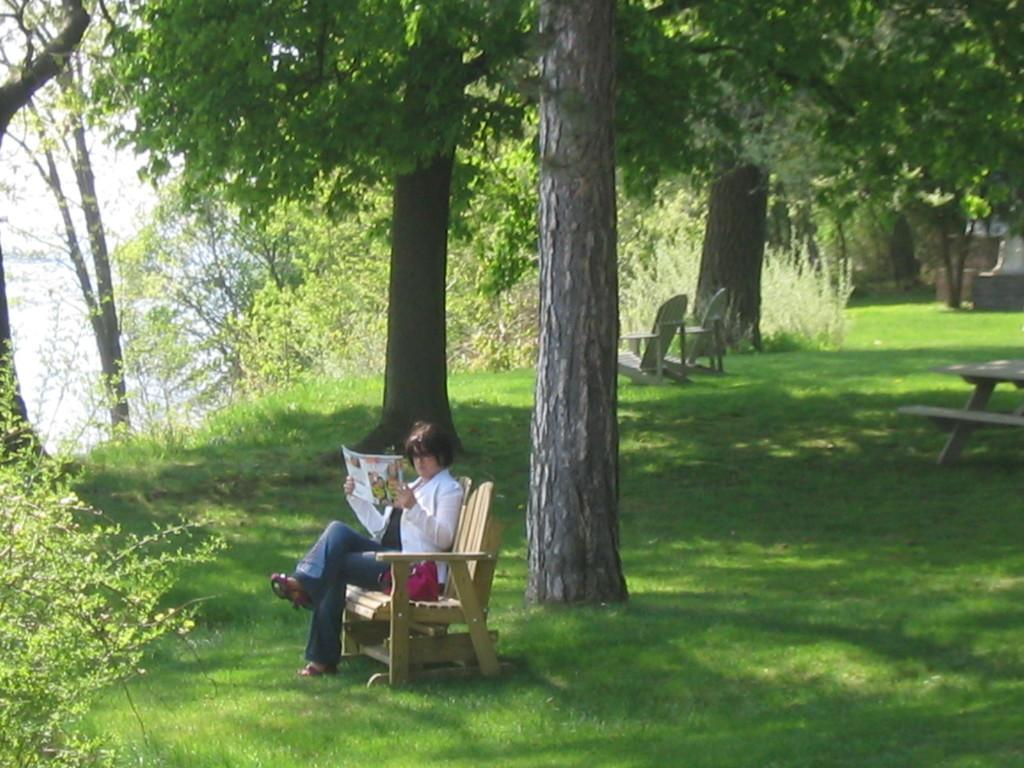What is the person in the image doing? The person is sitting on a bench in the image. What is the person holding while sitting on the bench? The person is holding a book. How many benches can be seen in the image? There are additional benches visible in the background. What type of vegetation is present in the background? Trees and grass are visible in the background. What type of event is the person attending in the image? There is no indication of an event in the image; it simply shows a person sitting on a bench holding a book. How does the person express disgust in the image? There is no indication of disgust in the image. 